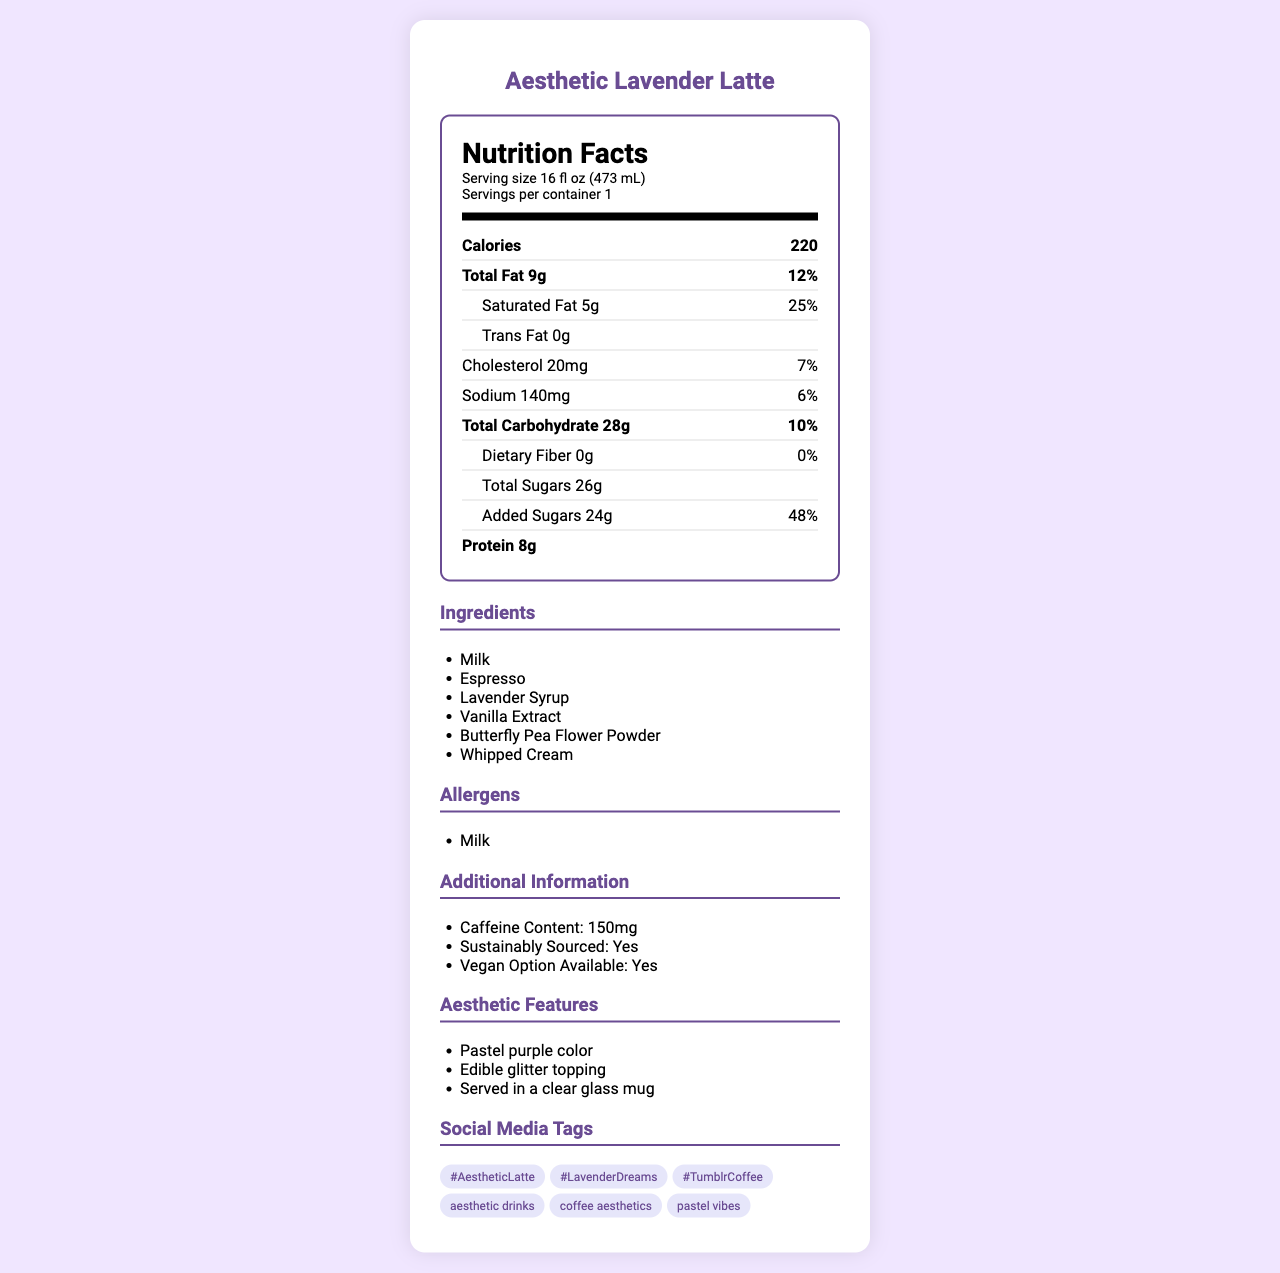what is the serving size? The serving size is mentioned at the top of the nutrition label under the header "Nutrition Facts".
Answer: 16 fl oz (473 mL) how many calories does the Aesthetic Lavender Latte contain per serving? The document clearly states that the product contains 220 calories per serving.
Answer: 220 What is the total carbohydrate content per serving? The total carbohydrate amount given in the document is 28 grams.
Answer: 28g what are the aesthetic features of the Aesthetic Lavender Latte? These features are listed under the section titled "Additional Information" and specifically under "Aesthetic Features".
Answer: Pastel purple color, Edible glitter topping, Served in a clear glass mug What ingredients might cause allergies for some people? The only allergen listed in the document is "Milk".
Answer: Milk Which of the following is the caffeine content of the Aesthetic Lavender Latte? A. 120mg B. 150mg C. 180mg D. 200mg The document states the caffeine content as 150mg under the "Additional Information" section.
Answer: B According to the document, what percentage of the daily value of saturated fat does the Aesthetic Lavender Latte provide? A. 10% B. 20% C. 25% D. 30% The daily value percentage for saturated fat is given as 25%.
Answer: C Is the Aesthetic Lavender Latte sustainably sourced? The document explicitly mentions that the product is "Sustainably Sourced: Yes" under "Additional Information".
Answer: Yes Is there a vegan option available for the Aesthetic Lavender Latte? The vegan option availability is specified as "Yes" in the "Additional Information" section.
Answer: Yes Summarize the main features provided in the nutrition facts and additional information of the Aesthetic Lavender Latte. This overview captures the key nutritional values, ingredients, allergens, aesthetics, sustainability, and social media tags mentioned in the document.
Answer: The Aesthetic Lavender Latte is a specialty coffee drink with 220 calories per serving, 9g of total fat, and 28g of carbohydrates. It contains allergenic milk and provides 150mg of caffeine. The beverage is sustainably sourced, vegan-friendly, and comes with pastel purple color, edible glitter, and a clear glass mug as its aesthetic features. It can be tagged using #AestheticLatte, #LavenderDreams on Instagram and "aesthetic drinks", "coffee aesthetics" on Tumblr. What is the total daily value percentage of cholesterol in the Aesthetic Lavender Latte? The daily value percentage for cholesterol is directly listed in the document.
Answer: 7% How much added sugars does the Aesthetic Lavender Latte contain? The document specifies that the product contains 24 grams of added sugars.
Answer: 24g Does the Aesthetic Lavender Latte contain any iron? The document mentions that the amount of iron is 0mg, indicating no iron content.
Answer: No List some of the social media tags suggested for the Aesthetic Lavender Latte. The tags are listed under the "Social Media Tags" section and include both Instagram hashtags and Tumblr tags.
Answer: #AestheticLatte, #LavenderDreams, #TumblrCoffee, aesthetic drinks, coffee aesthetics, pastel vibes What is the total fat content in grams? The total fat content is clearly stated as 9 grams in the nutrition facts section.
Answer: 9g How much vitamin D does the Aesthetic Lavender Latte provide? A. 1mcg B. 2mcg C. 3mcg D. 4mcg The document states that the vitamin D content is 2mcg.
Answer: B What is the primary coloring ingredient mentioned in the ingredients? This ingredient is listed among the product's components and is known for its vibrant color.
Answer: Butterfly Pea Flower Powder What is the weekly recommended limit of this drink for a balanced diet? The document does not provide any guidelines or recommendations regarding the weekly consumption limit for maintaining a balanced diet.
Answer: Not enough information 